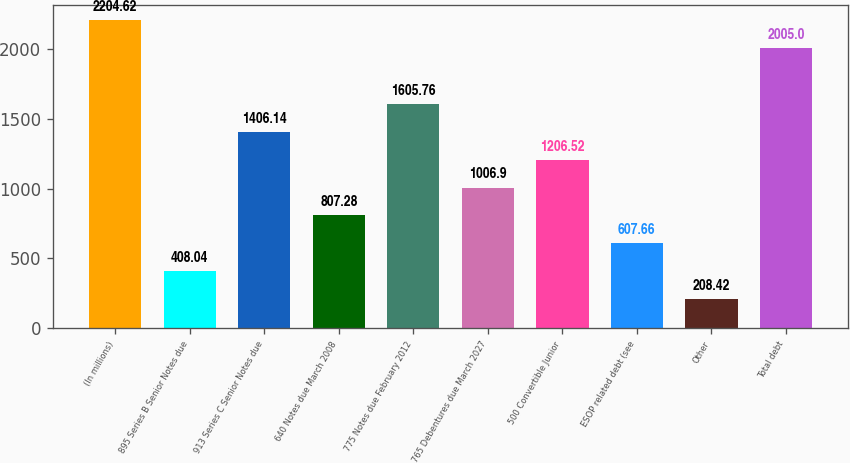Convert chart. <chart><loc_0><loc_0><loc_500><loc_500><bar_chart><fcel>(In millions)<fcel>895 Series B Senior Notes due<fcel>913 Series C Senior Notes due<fcel>640 Notes due March 2008<fcel>775 Notes due February 2012<fcel>765 Debentures due March 2027<fcel>500 Convertible Junior<fcel>ESOP related debt (see<fcel>Other<fcel>Total debt<nl><fcel>2204.62<fcel>408.04<fcel>1406.14<fcel>807.28<fcel>1605.76<fcel>1006.9<fcel>1206.52<fcel>607.66<fcel>208.42<fcel>2005<nl></chart> 